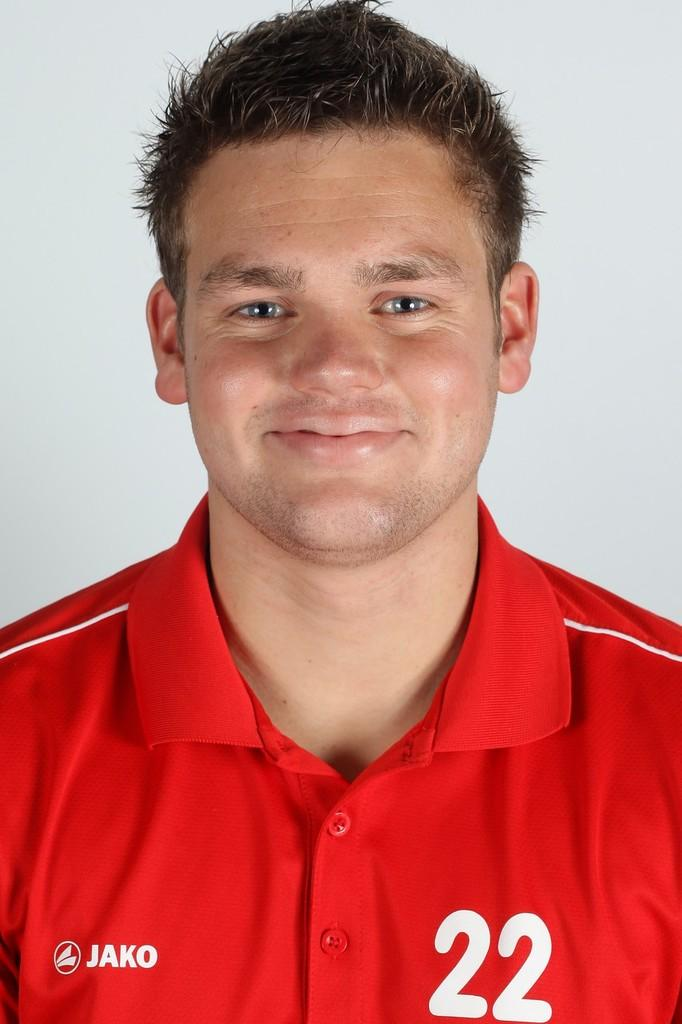<image>
Present a compact description of the photo's key features. A close up shot of a man wearing a red jersey with the Jako logo on his chest. 